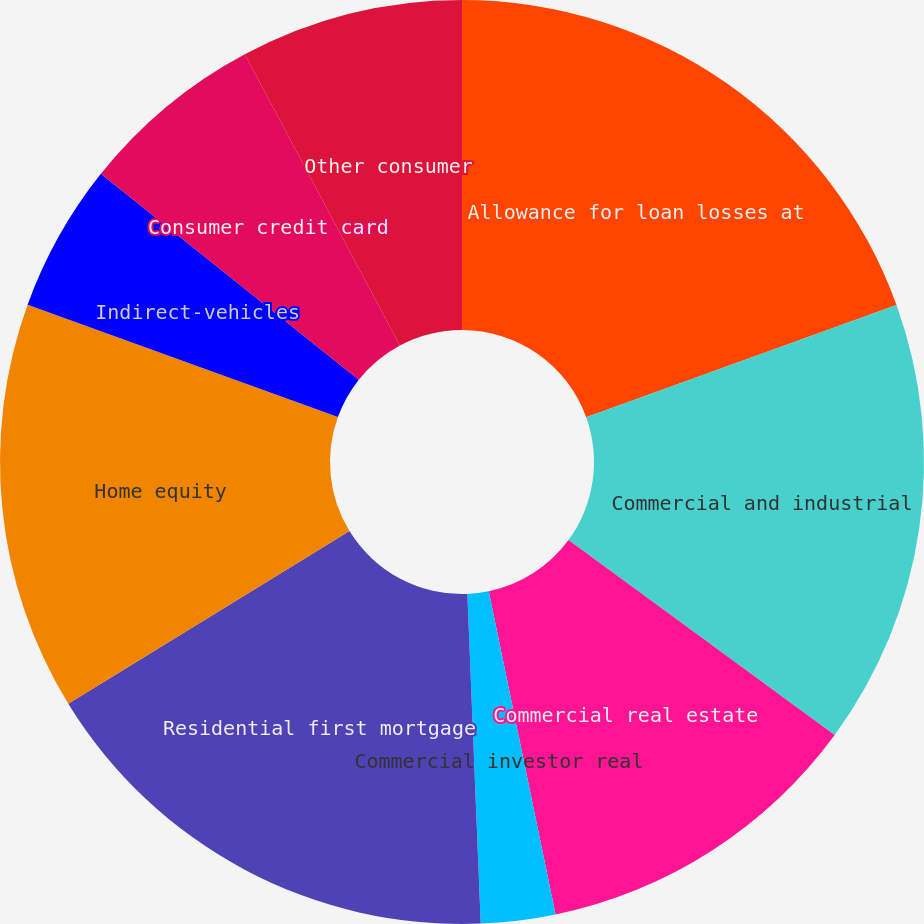Convert chart. <chart><loc_0><loc_0><loc_500><loc_500><pie_chart><fcel>Allowance for loan losses at<fcel>Commercial and industrial<fcel>Commercial real estate<fcel>Commercial investor real<fcel>Residential first mortgage<fcel>Home equity<fcel>Indirect-vehicles<fcel>Consumer credit card<fcel>Other consumer<nl><fcel>19.48%<fcel>15.58%<fcel>11.69%<fcel>2.6%<fcel>16.88%<fcel>14.29%<fcel>5.19%<fcel>6.49%<fcel>7.79%<nl></chart> 